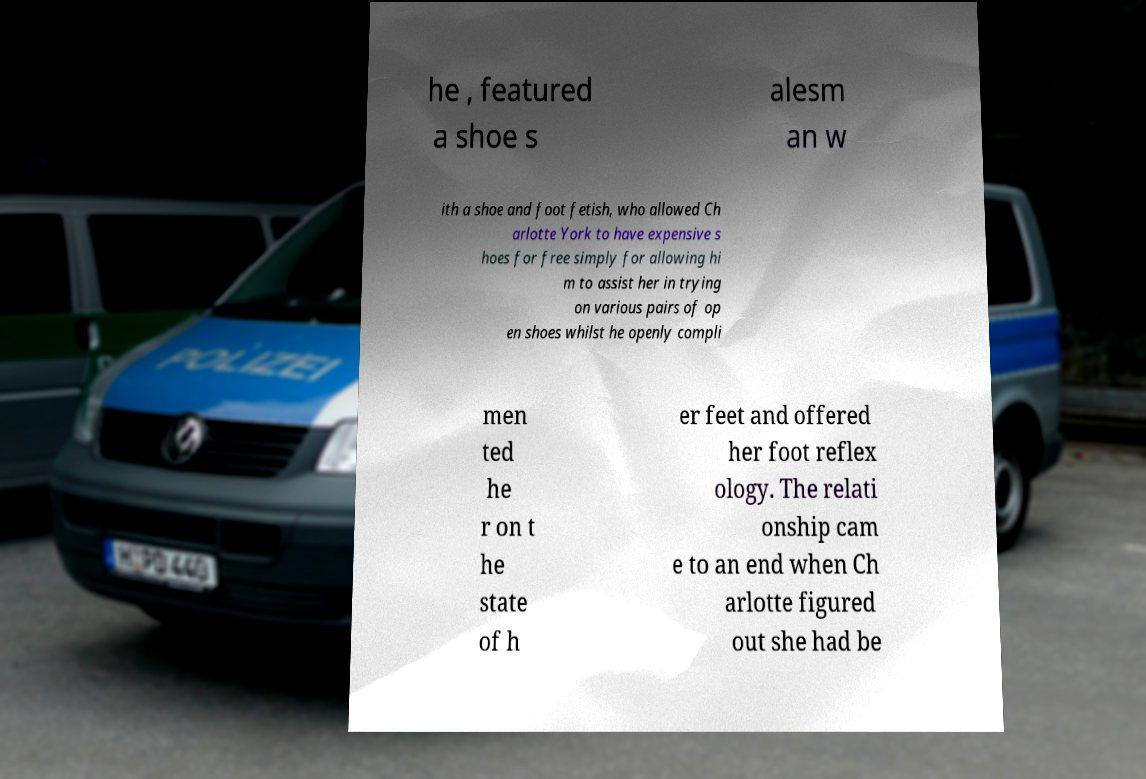There's text embedded in this image that I need extracted. Can you transcribe it verbatim? he , featured a shoe s alesm an w ith a shoe and foot fetish, who allowed Ch arlotte York to have expensive s hoes for free simply for allowing hi m to assist her in trying on various pairs of op en shoes whilst he openly compli men ted he r on t he state of h er feet and offered her foot reflex ology. The relati onship cam e to an end when Ch arlotte figured out she had be 